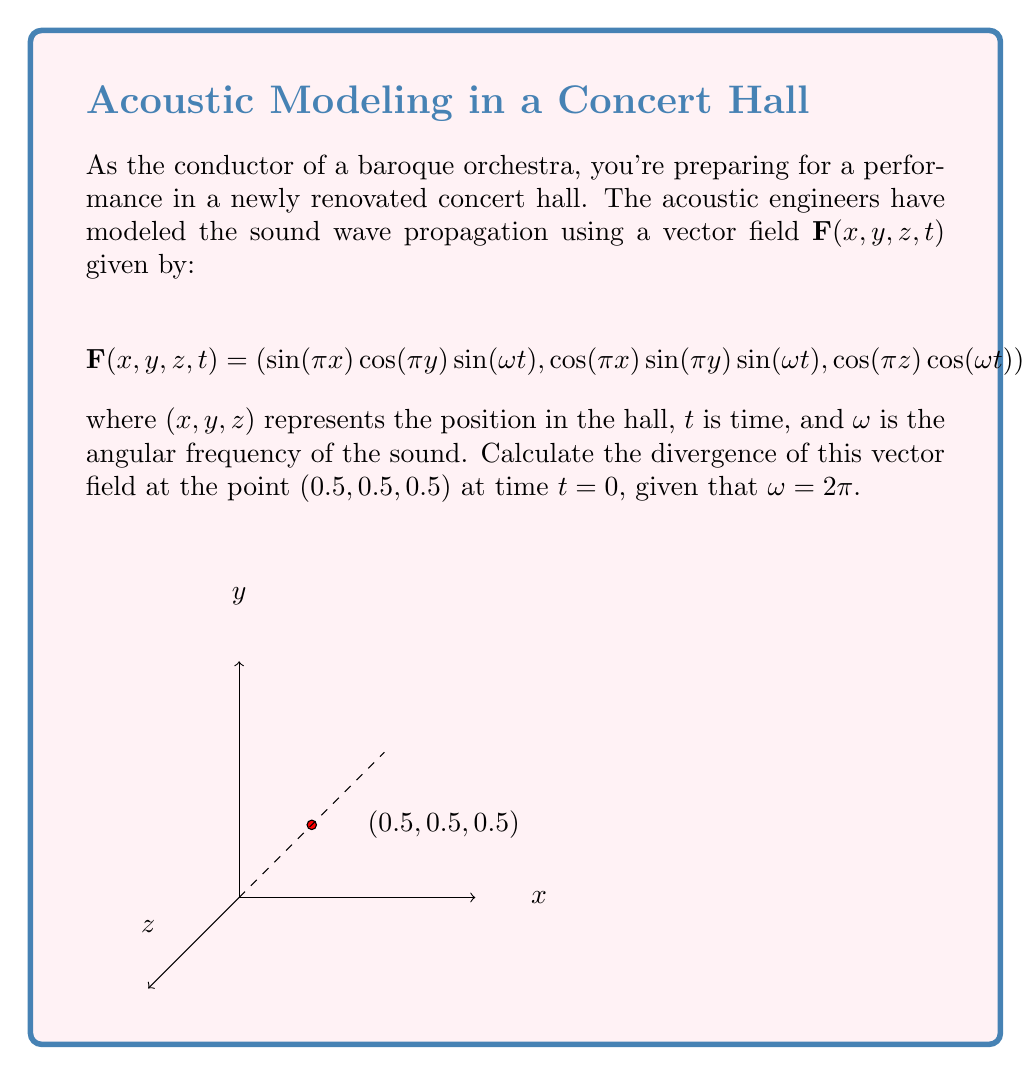Could you help me with this problem? Let's approach this step-by-step:

1) The divergence of a vector field $\mathbf{F}(x,y,z) = (F_x, F_y, F_z)$ is given by:

   $$\nabla \cdot \mathbf{F} = \frac{\partial F_x}{\partial x} + \frac{\partial F_y}{\partial y} + \frac{\partial F_z}{\partial z}$$

2) In our case, we need to find:
   
   $$\frac{\partial}{\partial x}(\sin(\pi x)\cos(\pi y)\sin(\omega t)) + \frac{\partial}{\partial y}(\cos(\pi x)\sin(\pi y)\sin(\omega t)) + \frac{\partial}{\partial z}(\cos(\pi z)\cos(\omega t))$$

3) Let's calculate each partial derivative:

   $$\frac{\partial F_x}{\partial x} = \pi \cos(\pi x)\cos(\pi y)\sin(\omega t)$$
   
   $$\frac{\partial F_y}{\partial y} = \pi \cos(\pi x)\cos(\pi y)\sin(\omega t)$$
   
   $$\frac{\partial F_z}{\partial z} = -\pi \sin(\pi z)\cos(\omega t)$$

4) Now, we need to evaluate these at the point $(0.5, 0.5, 0.5)$ and time $t=0$:

   At $x=0.5$: $\cos(\pi \cdot 0.5) = 0$
   At $y=0.5$: $\cos(\pi \cdot 0.5) = 0$
   At $z=0.5$: $\sin(\pi \cdot 0.5) = 1$
   At $t=0$ and $\omega = 2\pi$: $\sin(\omega t) = \sin(0) = 0$ and $\cos(\omega t) = \cos(0) = 1$

5) Substituting these values:

   $$\frac{\partial F_x}{\partial x} = \pi \cdot 0 \cdot 0 \cdot 0 = 0$$
   
   $$\frac{\partial F_y}{\partial y} = \pi \cdot 0 \cdot 0 \cdot 0 = 0$$
   
   $$\frac{\partial F_z}{\partial z} = -\pi \cdot 1 \cdot 1 = -\pi$$

6) The divergence is the sum of these partial derivatives:

   $$\nabla \cdot \mathbf{F} = 0 + 0 + (-\pi) = -\pi$$

Therefore, the divergence of the vector field at the point $(0.5, 0.5, 0.5)$ at time $t=0$ is $-\pi$.
Answer: $-\pi$ 